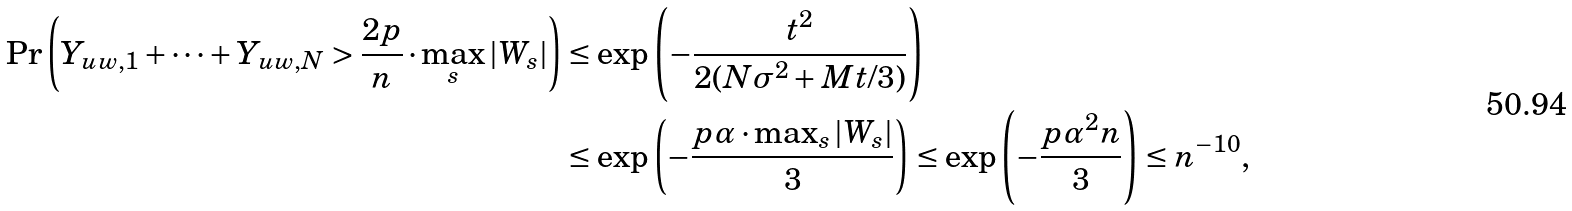Convert formula to latex. <formula><loc_0><loc_0><loc_500><loc_500>\Pr \left ( Y _ { u w , 1 } + \dots + Y _ { u w , N } > \frac { 2 p } { n } \cdot \max _ { s } | W _ { s } | \right ) & \leq \exp \left ( - \frac { t ^ { 2 } } { 2 ( N \sigma ^ { 2 } + M t / 3 ) } \right ) \\ & \leq \exp \left ( - \frac { p \alpha \cdot \max _ { s } | W _ { s } | } { 3 } \right ) \leq \exp \left ( - \frac { p \alpha ^ { 2 } n } { 3 } \right ) \leq n ^ { - 1 0 } ,</formula> 